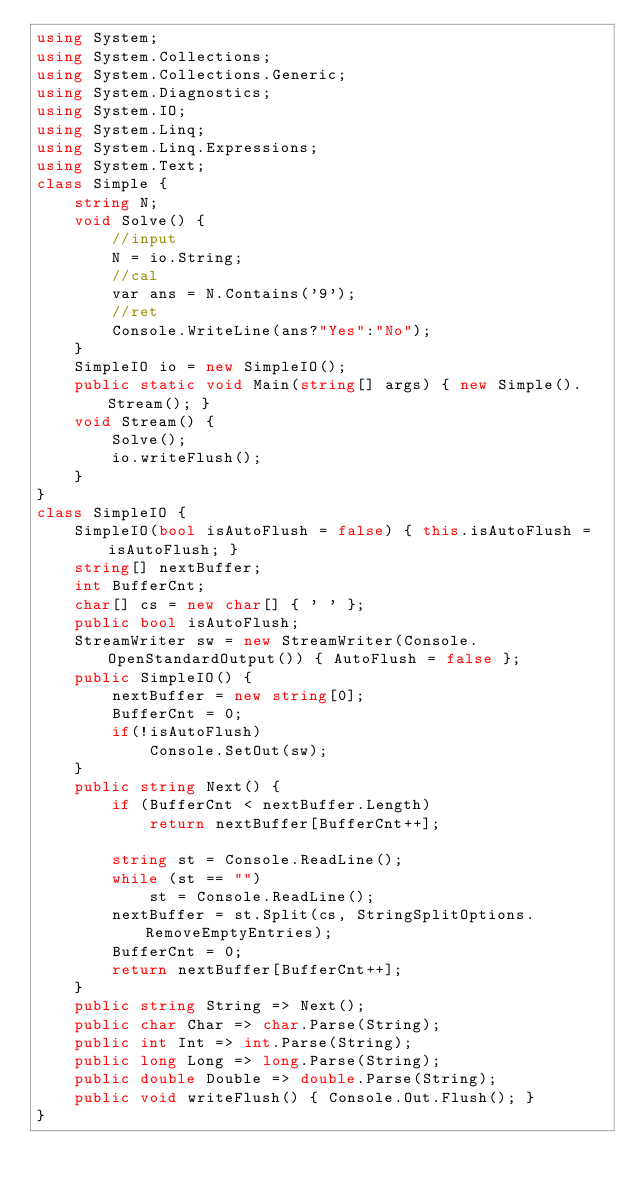Convert code to text. <code><loc_0><loc_0><loc_500><loc_500><_C#_>using System;
using System.Collections;
using System.Collections.Generic;
using System.Diagnostics;
using System.IO;
using System.Linq;
using System.Linq.Expressions;
using System.Text;
class Simple {
    string N;
    void Solve() {
        //input
        N = io.String;
        //cal
        var ans = N.Contains('9');
        //ret
        Console.WriteLine(ans?"Yes":"No");
    }
    SimpleIO io = new SimpleIO();
    public static void Main(string[] args) { new Simple().Stream(); }
    void Stream() {
        Solve();
        io.writeFlush();
    }
}
class SimpleIO {
    SimpleIO(bool isAutoFlush = false) { this.isAutoFlush = isAutoFlush; }
    string[] nextBuffer;
    int BufferCnt;
    char[] cs = new char[] { ' ' };
    public bool isAutoFlush;
    StreamWriter sw = new StreamWriter(Console.OpenStandardOutput()) { AutoFlush = false };
    public SimpleIO() {
        nextBuffer = new string[0];
        BufferCnt = 0;
        if(!isAutoFlush)
            Console.SetOut(sw);
    }
    public string Next() {
        if (BufferCnt < nextBuffer.Length)
            return nextBuffer[BufferCnt++];

        string st = Console.ReadLine();
        while (st == "")
            st = Console.ReadLine();
        nextBuffer = st.Split(cs, StringSplitOptions.RemoveEmptyEntries);
        BufferCnt = 0;
        return nextBuffer[BufferCnt++];
    }
    public string String => Next();
    public char Char => char.Parse(String);
    public int Int => int.Parse(String);
    public long Long => long.Parse(String);
    public double Double => double.Parse(String);
    public void writeFlush() { Console.Out.Flush(); }
}
</code> 